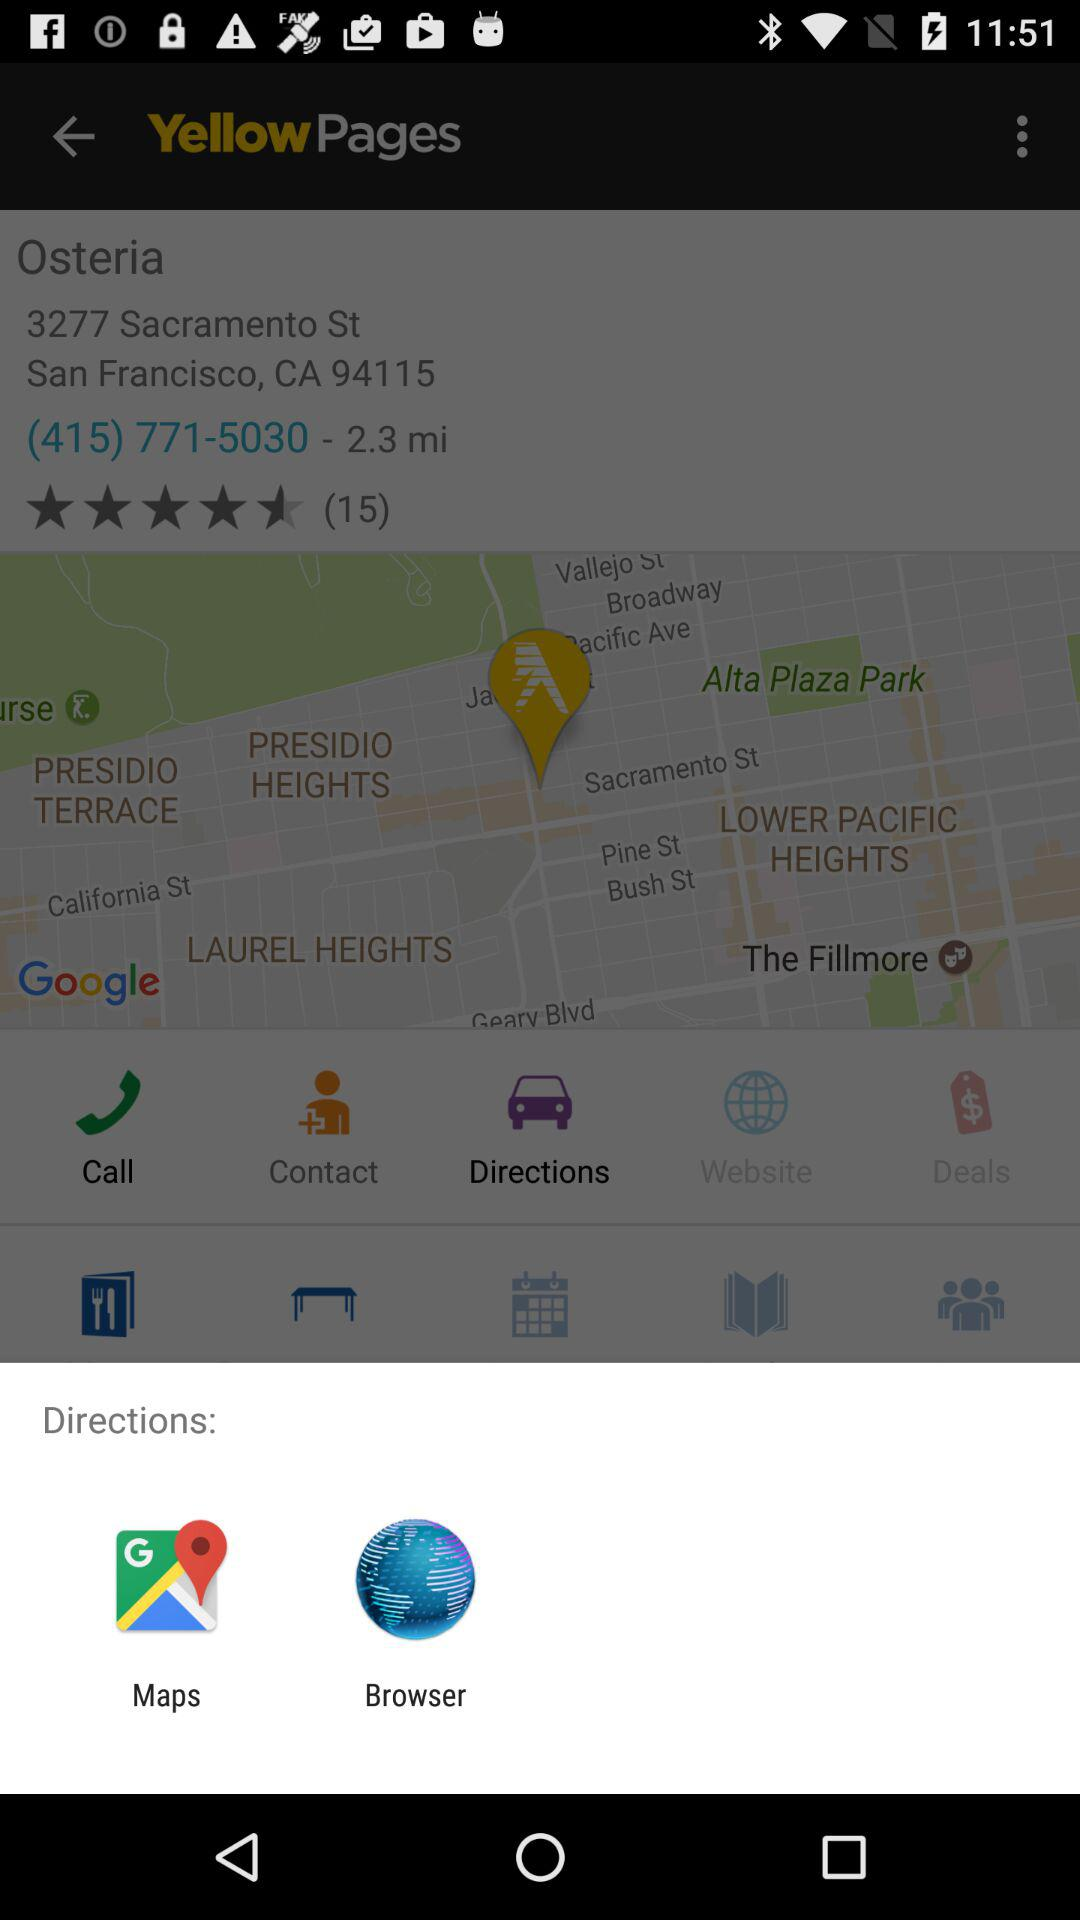What applications can be used to share? The applications that can be used to share are "Maps" and "Browser". 